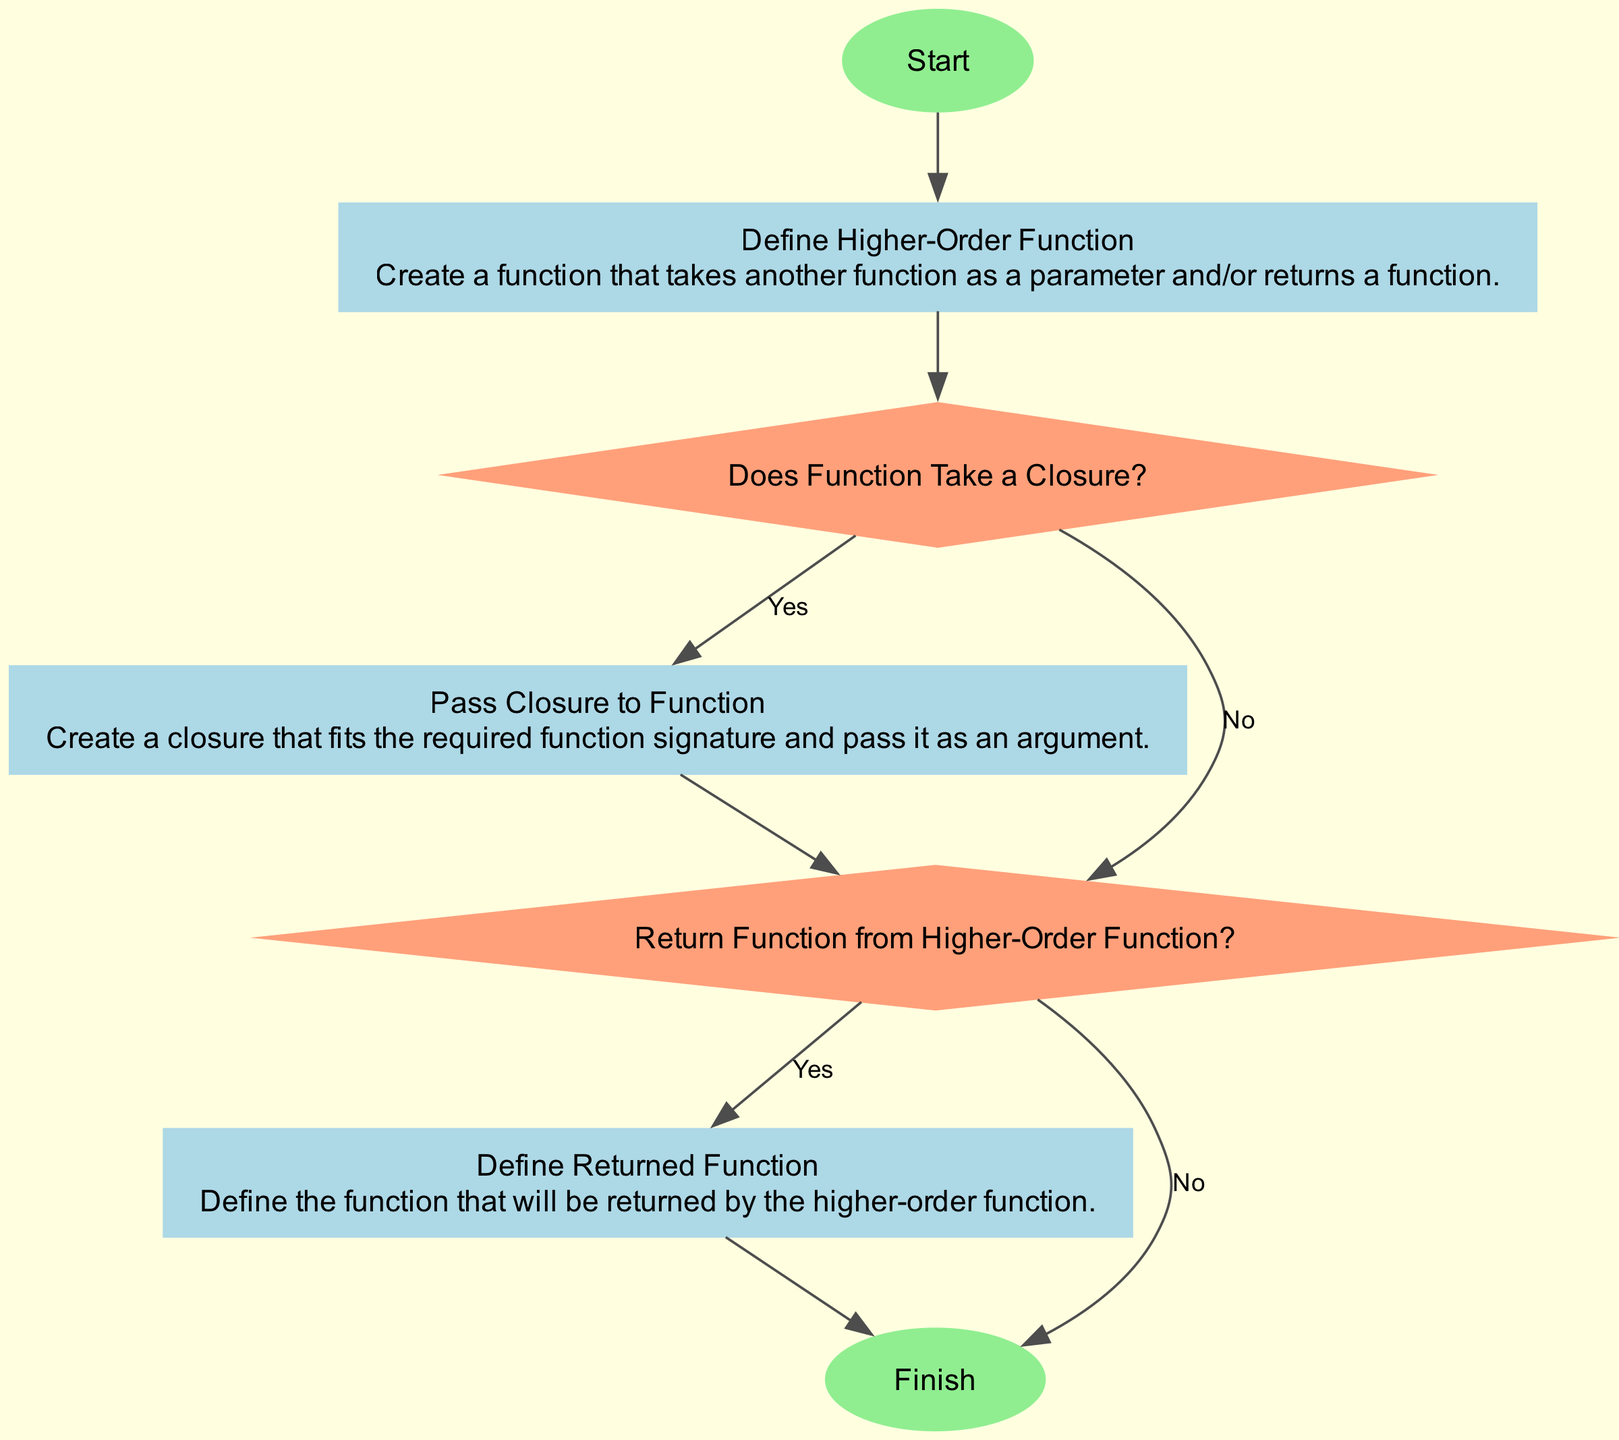What is the first step in the flow chart? The first step is marked as the "Start" node. This is the initial point in the flow chart where the process begins.
Answer: Start What type of node follows the Start node? After the Start node, the flow chart transitions to a "process" type node labeled "Define Higher-Order Function." This indicates that a function is defined in this step.
Answer: Process How many decision nodes are in the flow chart? There are two decision nodes: "Does Function Take a Closure?" and "Return Function from Higher-Order Function?" which are used to determine paths in the flow chart.
Answer: Two What condition leads to the "Define Returned Function" node? The condition that leads to the "Define Returned Function" node is "Yes," which arises from the decision node "Return Function from Higher-Order Function?" indicating that the higher-order function will return a function.
Answer: Yes What does the "Pass Closure to Function" node entail? The "Pass Closure to Function" node describes creating a closure that matches a specific function signature and passing it as an argument to the defined higher-order function.
Answer: Creating a closure What is the final step in the flow chart? The final step, as indicated by the last node, is labeled "Finish." This node signifies the end of the process detailed in the flow chart.
Answer: Finish What happens after defining the higher-order function? After defining the higher-order function, the next step involves a decision titled "Does Function Take a Closure?" which involves determining whether the function accepts a closure as a parameter.
Answer: Decision on closure What leads to the process of defining the returned function? The process of defining the returned function is reached if the decision is "Yes" from "Return Function from Higher-Order Function?" indicating the need to define what the function will return.
Answer: Decision "Yes" What is the relationship between the "Does Function Take a Closure?" and "Pass Closure to Function" nodes? The "Does Function Take a Closure?" node determines if a closure will be created, and if "Yes," the flow moves to the "Pass Closure to Function" node where the closure is created and passed as an argument.
Answer: Conditional flow 